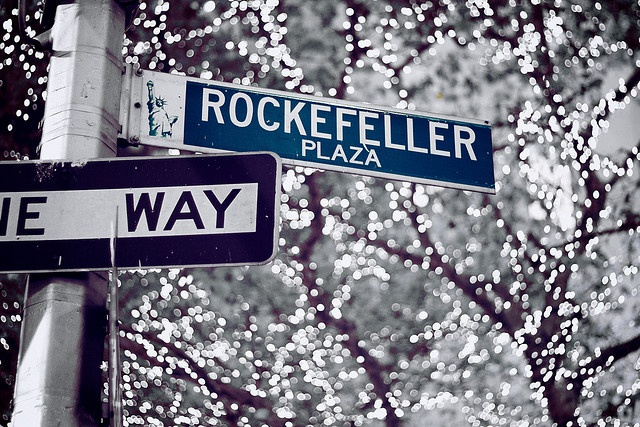Describe the objects in this image and their specific colors. I can see various objects in this image with different colors. 